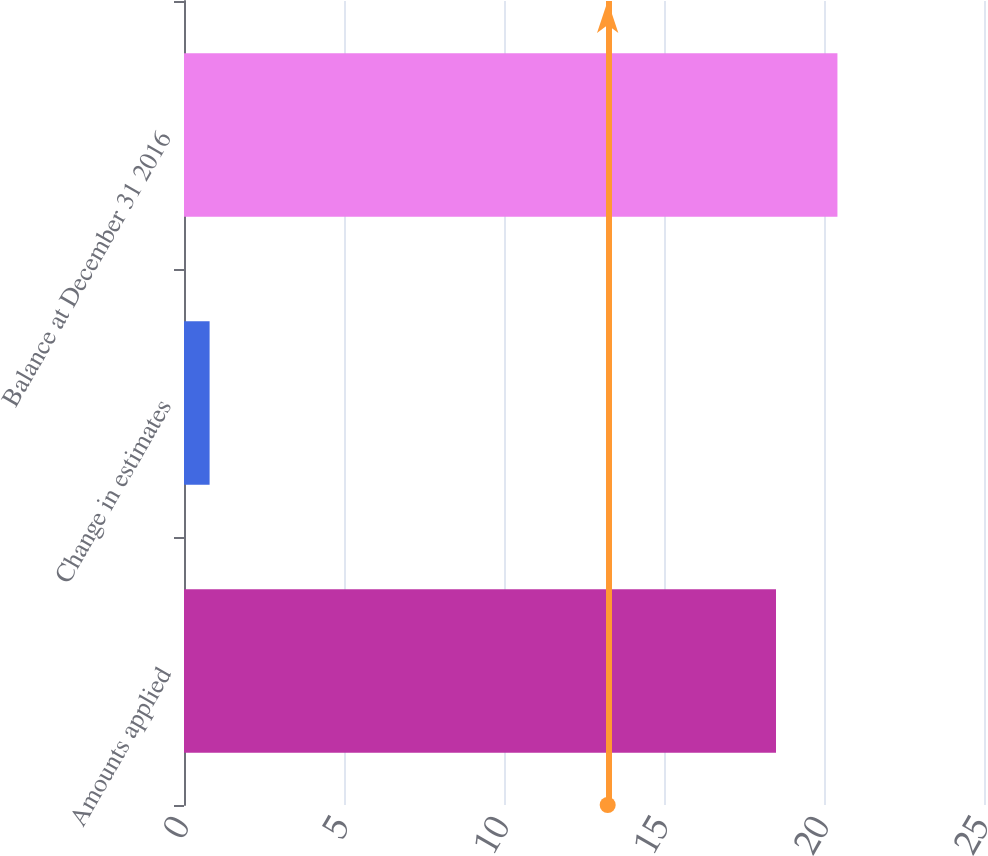Convert chart to OTSL. <chart><loc_0><loc_0><loc_500><loc_500><bar_chart><fcel>Amounts applied<fcel>Change in estimates<fcel>Balance at December 31 2016<nl><fcel>18.5<fcel>0.8<fcel>20.42<nl></chart> 